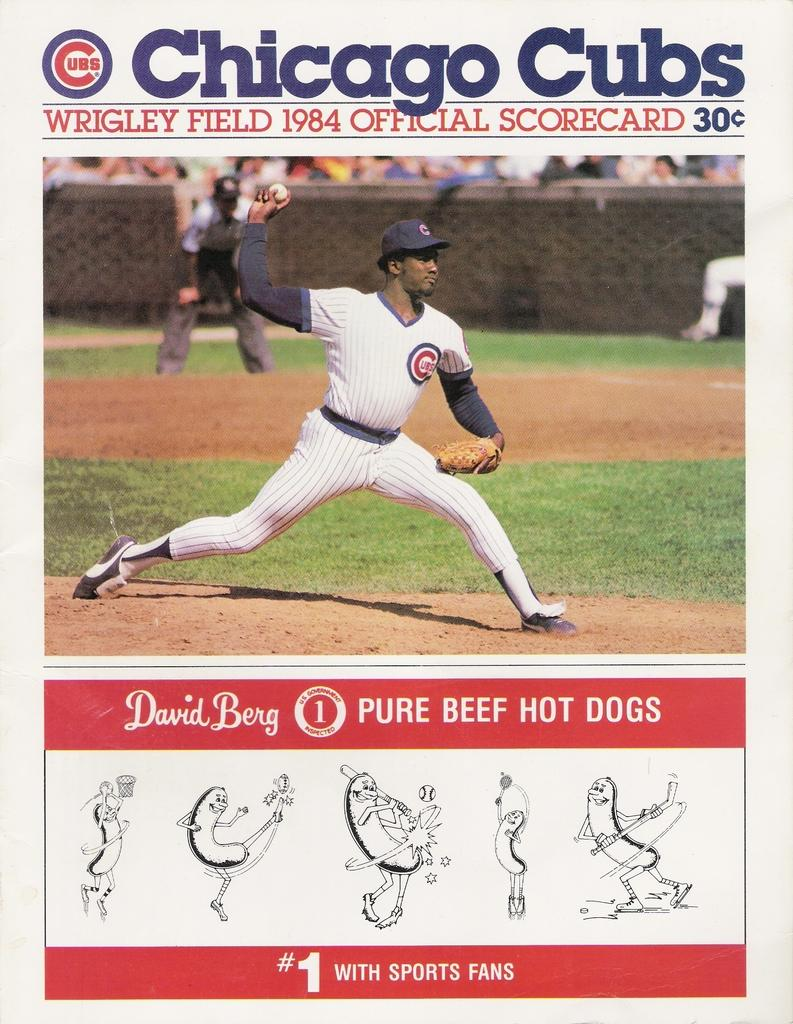<image>
Provide a brief description of the given image. An official Chicago Cubs scorecard from 1984 contains an ad for David Berg beef hotdogs. 